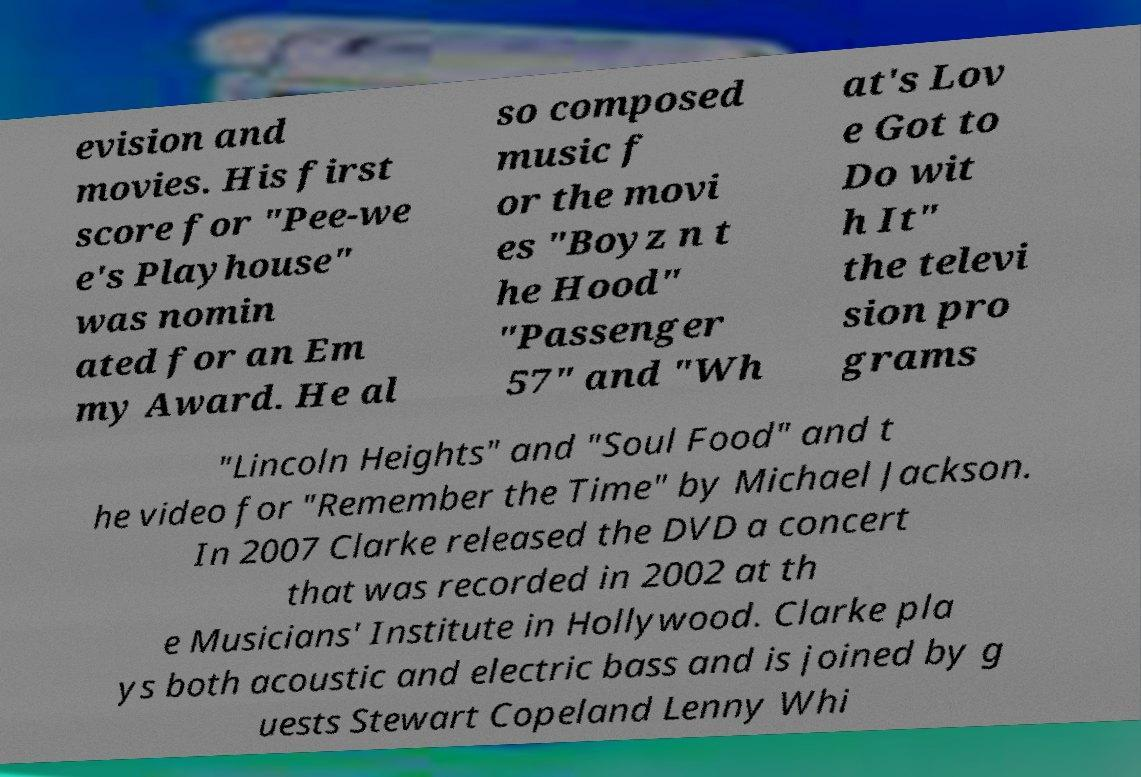Can you accurately transcribe the text from the provided image for me? evision and movies. His first score for "Pee-we e's Playhouse" was nomin ated for an Em my Award. He al so composed music f or the movi es "Boyz n t he Hood" "Passenger 57" and "Wh at's Lov e Got to Do wit h It" the televi sion pro grams "Lincoln Heights" and "Soul Food" and t he video for "Remember the Time" by Michael Jackson. In 2007 Clarke released the DVD a concert that was recorded in 2002 at th e Musicians' Institute in Hollywood. Clarke pla ys both acoustic and electric bass and is joined by g uests Stewart Copeland Lenny Whi 